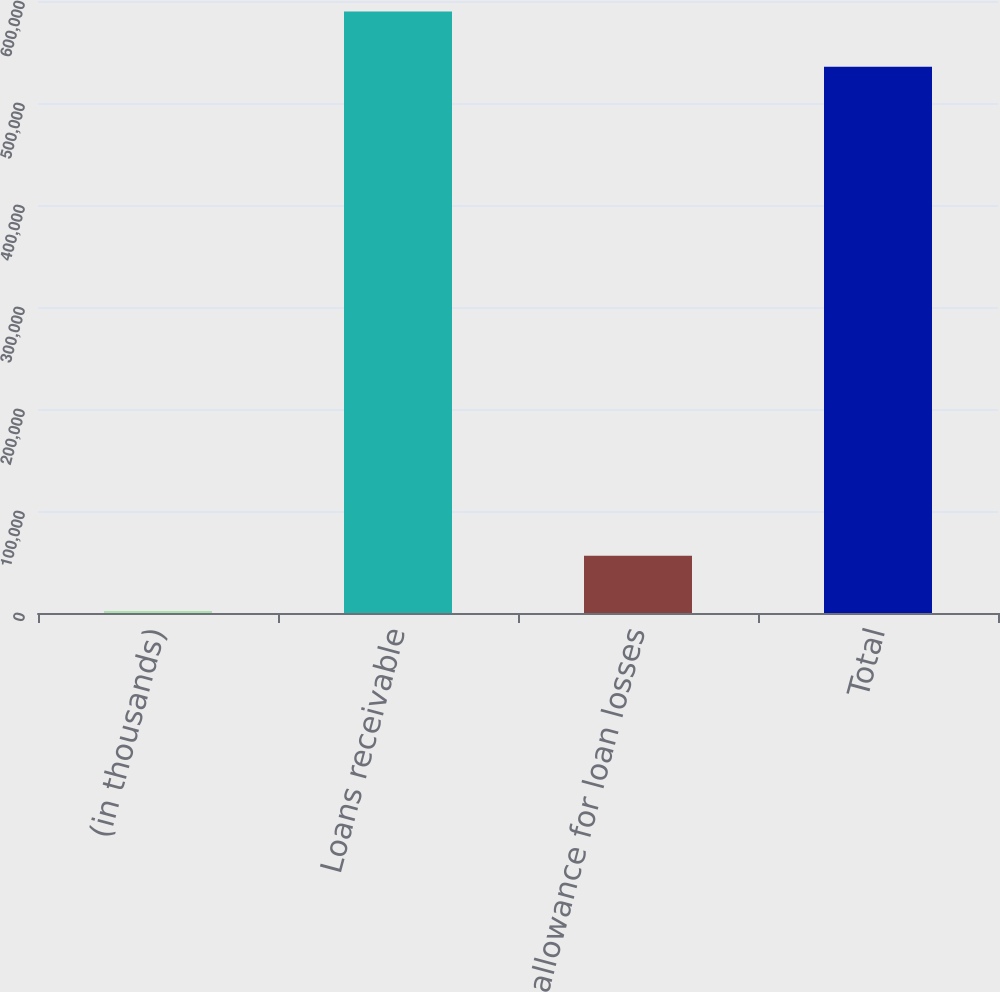<chart> <loc_0><loc_0><loc_500><loc_500><bar_chart><fcel>(in thousands)<fcel>Loans receivable<fcel>Less allowance for loan losses<fcel>Total<nl><fcel>2011<fcel>589722<fcel>56127.5<fcel>535606<nl></chart> 